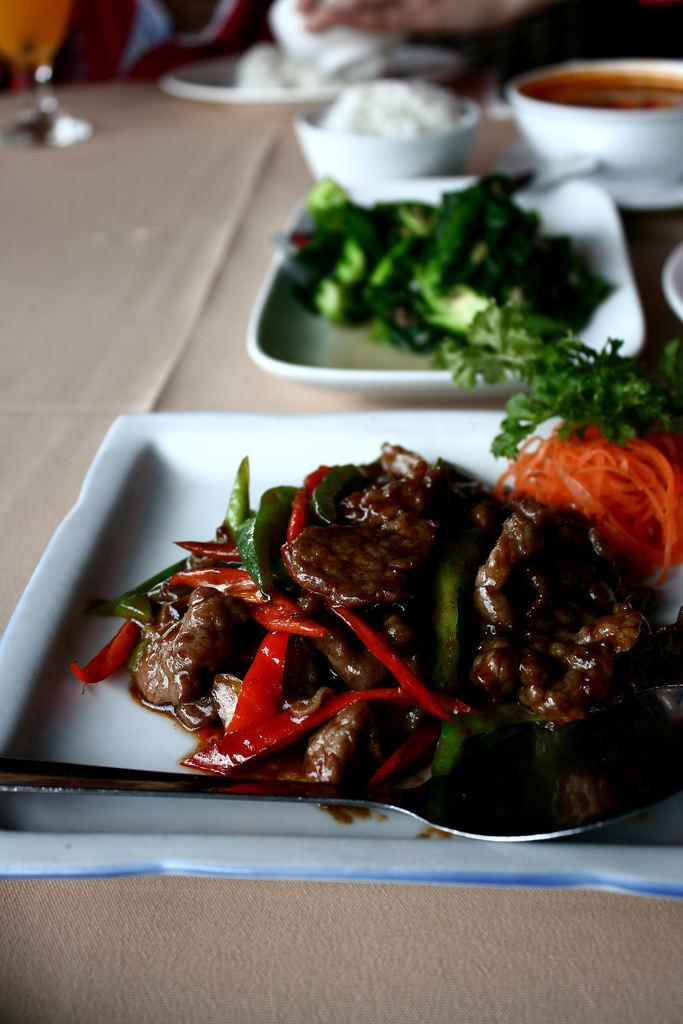What is present on the table in the image? There are plates and bowls with food on the table in the image. What else can be seen on the table besides the plates and bowls? There is a glass visible on the table. Can you describe the utensil that is visible in a plate? A spoon is visible in a plate. Who might be holding the bowl in the image? A person's hand is holding a bowl in the image. What type of rice is being ordered by the person in the image? There is no indication in the image that a person is ordering rice or any other food item. 